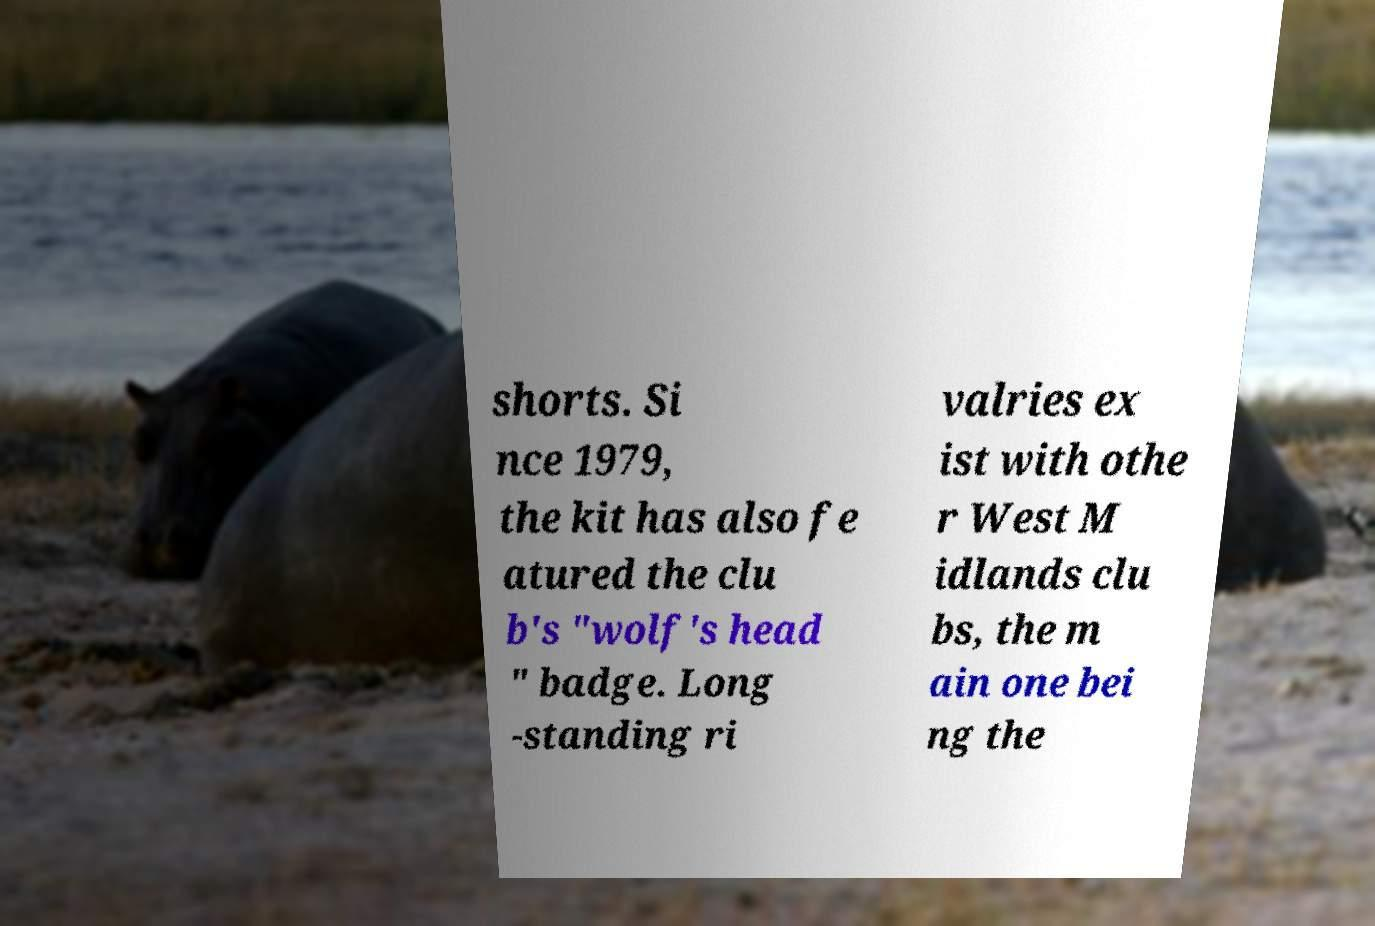Can you accurately transcribe the text from the provided image for me? shorts. Si nce 1979, the kit has also fe atured the clu b's "wolf's head " badge. Long -standing ri valries ex ist with othe r West M idlands clu bs, the m ain one bei ng the 